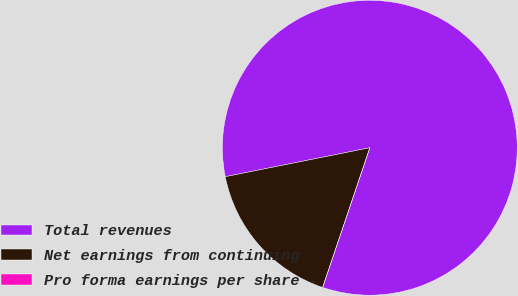<chart> <loc_0><loc_0><loc_500><loc_500><pie_chart><fcel>Total revenues<fcel>Net earnings from continuing<fcel>Pro forma earnings per share -<nl><fcel>83.33%<fcel>16.67%<fcel>0.0%<nl></chart> 